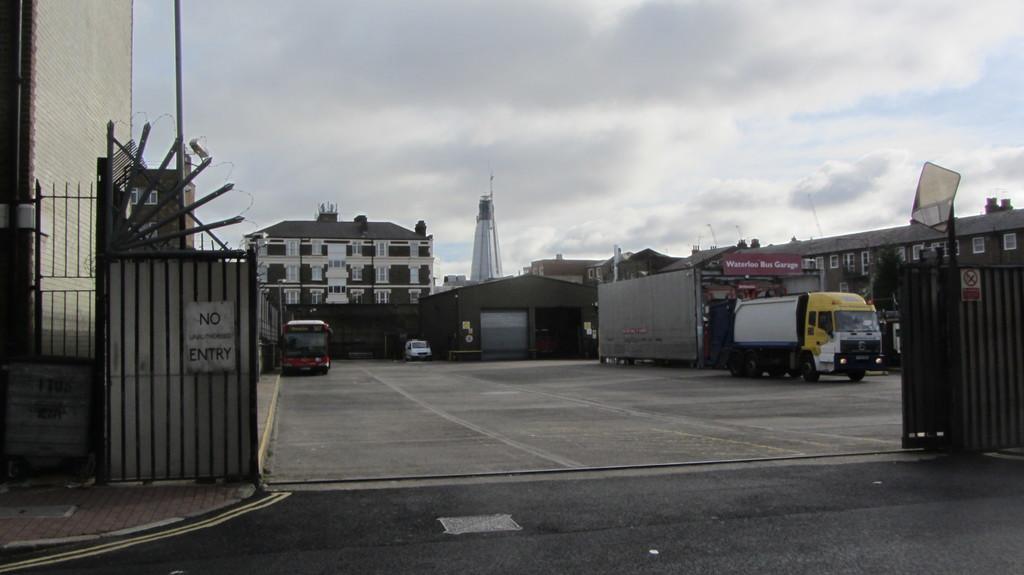How would you summarize this image in a sentence or two? In this picture I can observe buildings in the middle of the picture. I can observe gate on the left side and right side. In the background I can observe clouds in the sky. 